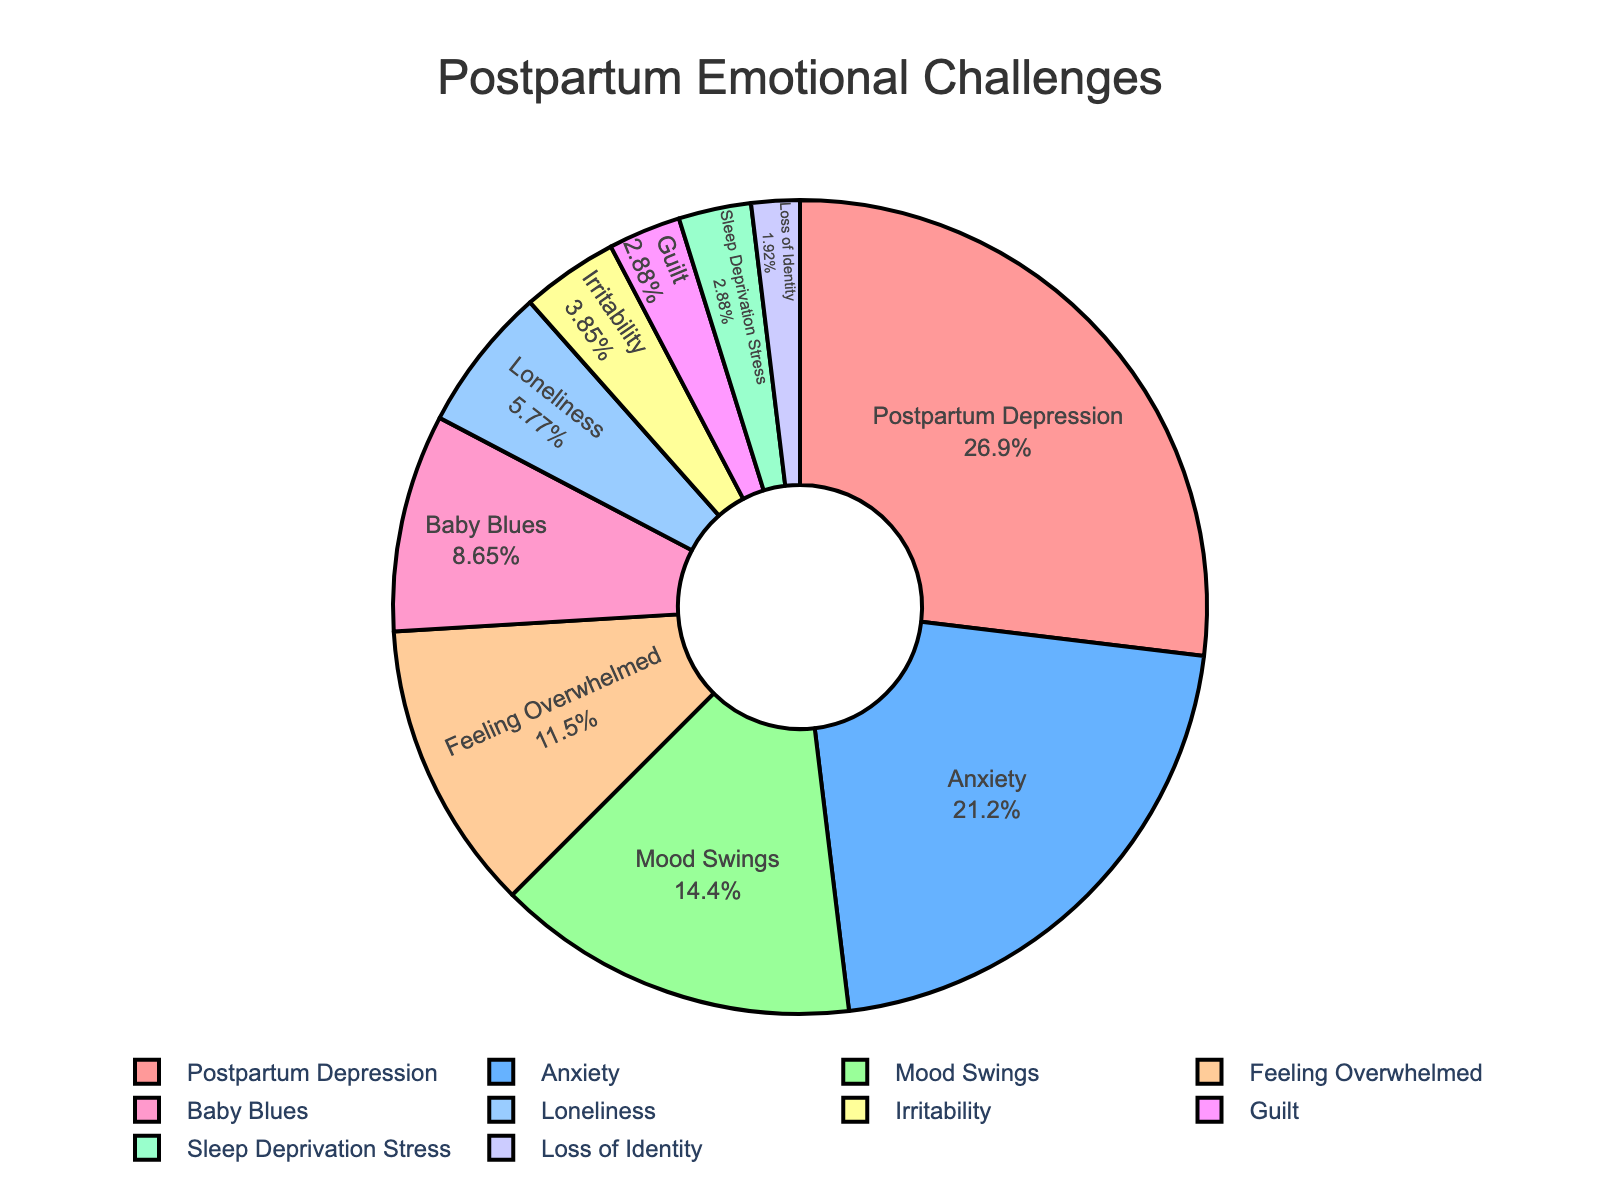Which emotional challenge is reported the most by mothers in online support groups? The largest section of the pie chart is labeled "Postpartum Depression" and takes up the biggest percentage.
Answer: Postpartum Depression Which two emotional challenges collectively form exactly 12% of the responses? The sections labeled "Baby Blues" and "Loneliness" have percentages of 9% and 6%, respectively.
Answer: Baby Blues and Loneliness How much larger is the percentage of mothers reporting Postpartum Depression compared to those reporting Anxiety? Postpartum Depression is reported at 28%, while Anxiety is reported at 22%. Subtracting these gives 28% - 22% = 6%.
Answer: 6% If we combine the percentages for Mood Swings and Feeling Overwhelmed, how much does it add up to? Mood Swings occupies 15% and Feeling Overwhelmed occupies 12%. Adding these gives 15% + 12% = 27%.
Answer: 27% Which emotional challenge occupies a smaller section of the pie chart: Guilt or Loss of Identity? The section for Guilt is 3%, while the section for Loss of Identity is 2%. Therefore, Loss of Identity occupies a smaller section.
Answer: Loss of Identity Which emotional challenge is represented by a yellow-colored segment in the pie chart? The yellow-colored segment in the pie chart corresponds with "Baby Blues."
Answer: Baby Blues What is the combined percentage of mothers who report experiencing Irritability, Guilt, Sleep Deprivation Stress, and Loss of Identity? Adding the percentages together: Irritability (4%), Guilt (3%), Sleep Deprivation Stress (3%), and Loss of Identity (2%), we get 4% + 3% + 3% + 2% = 12%.
Answer: 12% Is the percentage of mothers experiencing Anxiety greater or less than the combined percentage of those experiencing Sleep Deprivation Stress and Loss of Identity? Anxiety is reported at 22%, while the combined percentage for Sleep Deprivation Stress (3%) and Loss of Identity (2%) is 3% + 2% = 5%. 22% is greater than 5%.
Answer: Greater How does the percentage of mothers feeling Overwhelmed compare to those reporting Mood Swings? The percentage for Feeling Overwhelmed is 12%, while for Mood Swings it is 15%. Therefore, Feeling Overwhelmed is less than Mood Swings.
Answer: Less 